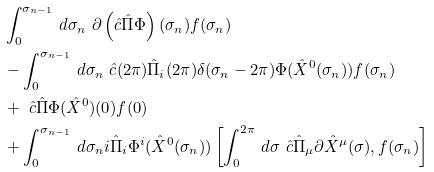Convert formula to latex. <formula><loc_0><loc_0><loc_500><loc_500>& \int _ { 0 } ^ { \sigma _ { n - 1 } } \, d \sigma _ { n } \ \partial \left ( \hat { c } \hat { \Pi } \Phi \right ) ( \sigma _ { n } ) f ( \sigma _ { n } ) \\ & - \int _ { 0 } ^ { \sigma _ { n - 1 } } \, d \sigma _ { n } \ \hat { c } ( 2 \pi ) \hat { \Pi } _ { i } ( 2 \pi ) \delta ( \sigma _ { n } - 2 \pi ) \Phi ( \hat { X } ^ { 0 } ( \sigma _ { n } ) ) f ( \sigma _ { n } ) \\ & + \ \hat { c } \hat { \Pi } \Phi ( \hat { X } ^ { 0 } ) ( 0 ) f ( 0 ) \\ & + \int _ { 0 } ^ { \sigma _ { n - 1 } } \, d \sigma _ { n } i \hat { \Pi } _ { i } \Phi ^ { i } ( \hat { X } ^ { 0 } ( \sigma _ { n } ) ) \left [ \int _ { 0 } ^ { 2 \pi } \, d \sigma \ \hat { c } \hat { \Pi } _ { \mu } \partial \hat { X } ^ { \mu } ( \sigma ) , f ( \sigma _ { n } ) \right ] \\</formula> 